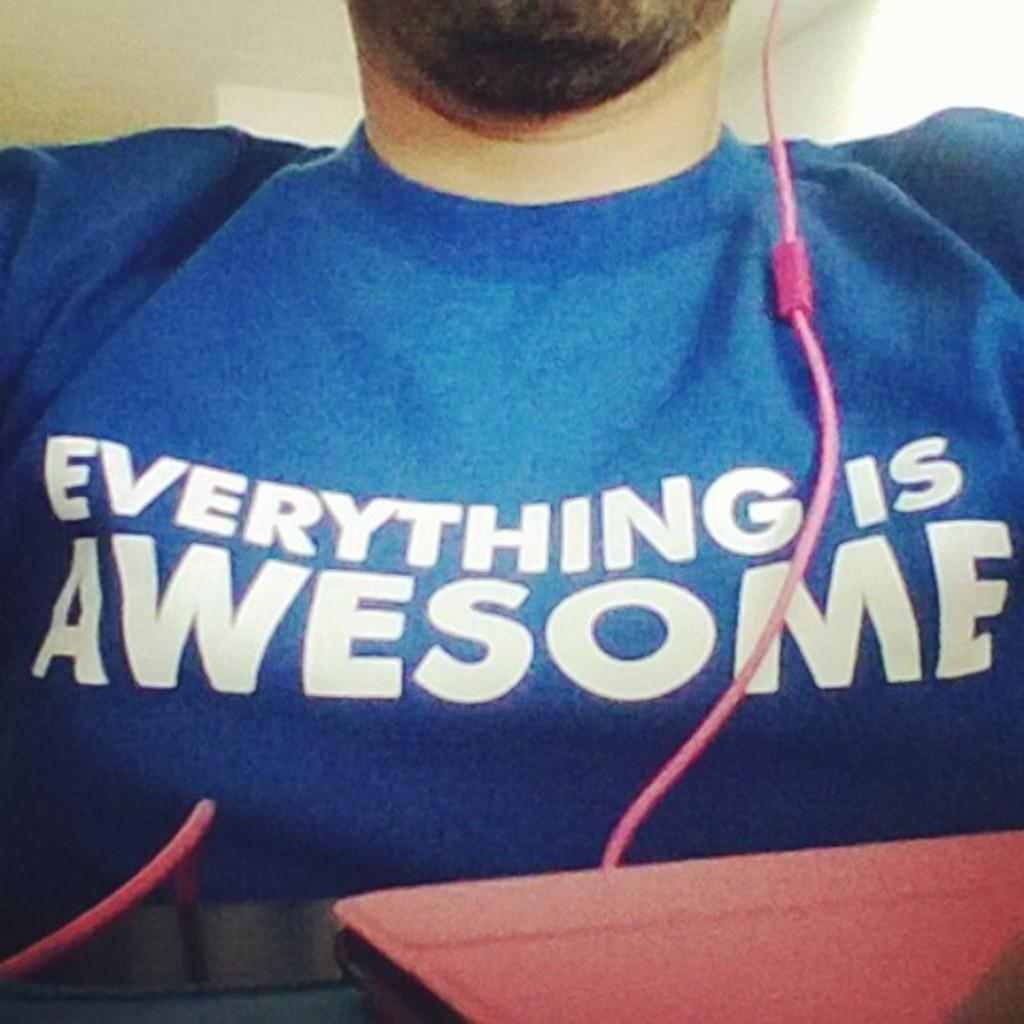Provide a one-sentence caption for the provided image. A closeup of a man wearing a blue shirt reading EVERYTHING IS AWESOME. 